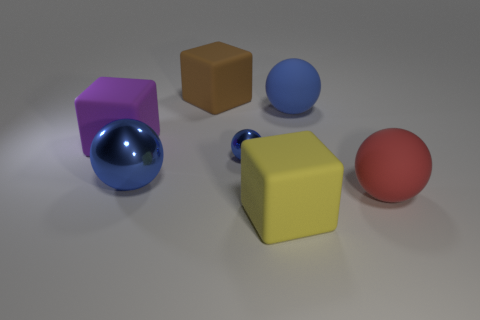How many blue balls must be subtracted to get 1 blue balls? 2 Subtract all blue balls. How many balls are left? 1 Add 2 yellow matte things. How many objects exist? 9 Subtract all purple cubes. How many cubes are left? 2 Subtract all balls. How many objects are left? 3 Subtract all gray cylinders. How many yellow balls are left? 0 Subtract all large blue rubber things. Subtract all metal spheres. How many objects are left? 4 Add 2 yellow things. How many yellow things are left? 3 Add 6 purple matte cubes. How many purple matte cubes exist? 7 Subtract 0 cyan blocks. How many objects are left? 7 